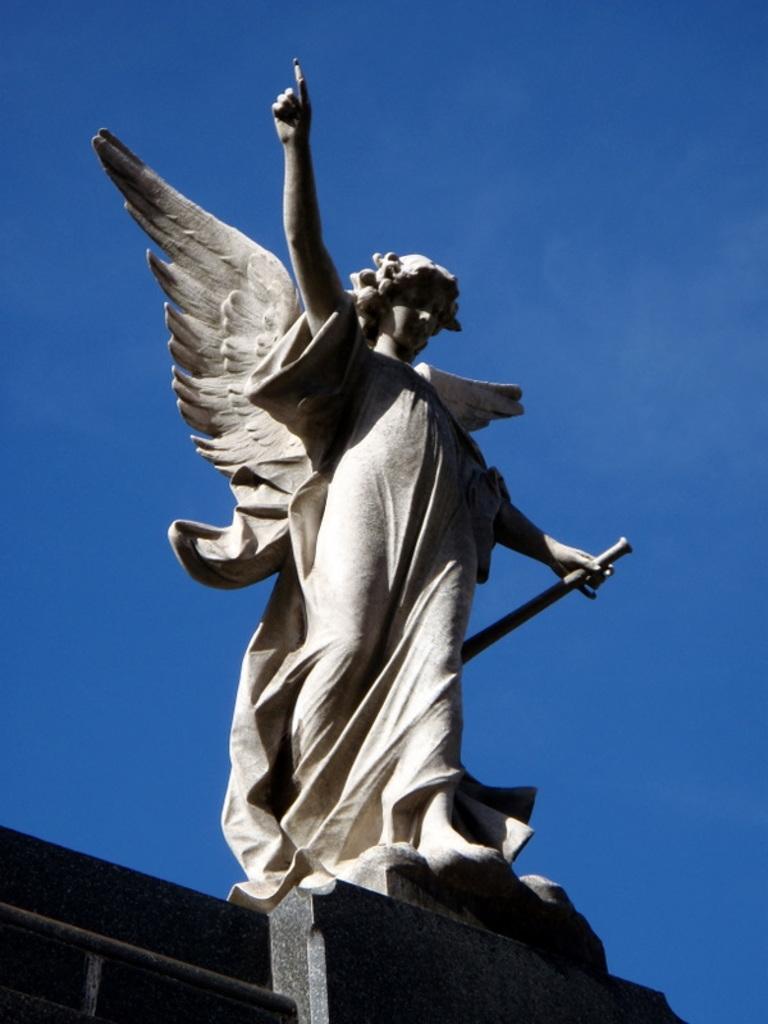Can you describe this image briefly? In the center of the image a statue is there. In the background of the image sky is there. At the bottom of the image wall is there. 